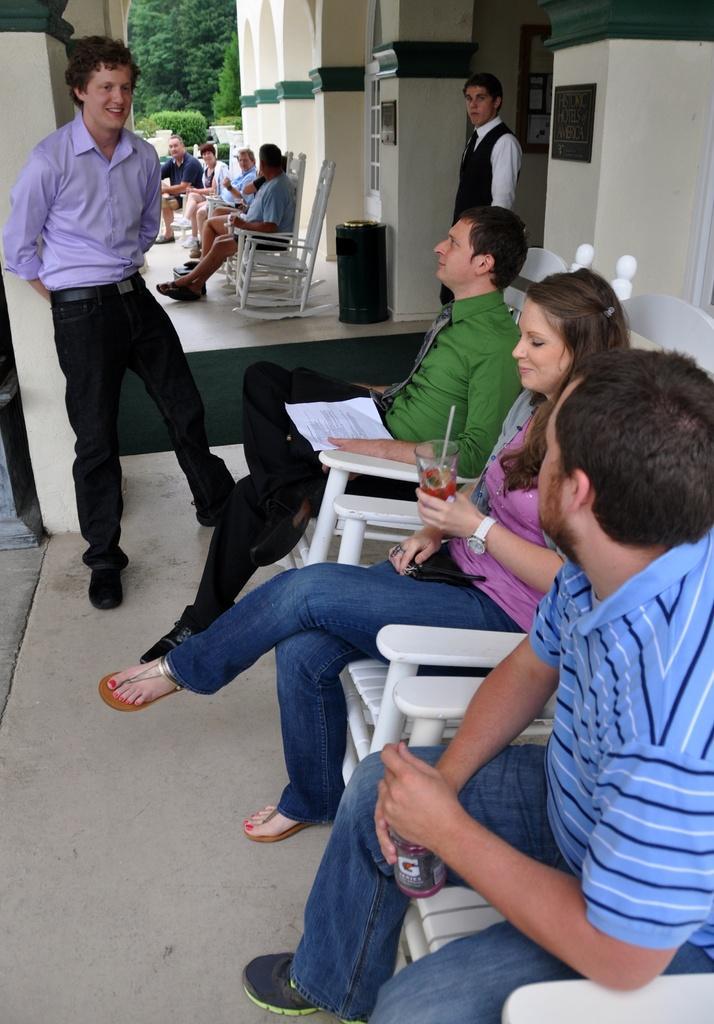How would you summarize this image in a sentence or two? In this image, I can see groups of people sitting on the chairs and two persons standing on the floor. I can see a dustbin and photo frames attached to the wall. In the background, there are trees. 